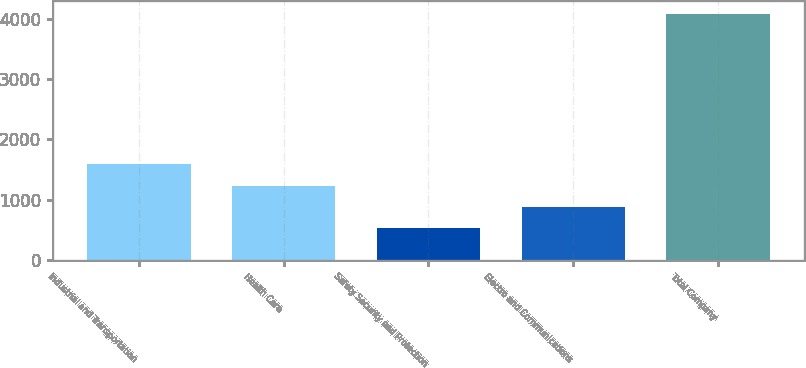Convert chart. <chart><loc_0><loc_0><loc_500><loc_500><bar_chart><fcel>Industrial and Transportation<fcel>Health Care<fcel>Safety Security and Protection<fcel>Electro and Communications<fcel>Total Company<nl><fcel>1592.1<fcel>1236.4<fcel>525<fcel>880.7<fcel>4082<nl></chart> 